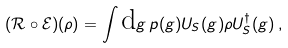<formula> <loc_0><loc_0><loc_500><loc_500>( \mathcal { R } \circ \mathcal { E } ) ( \rho ) = \int \text {d} g \, p ( g ) U _ { S } ( g ) \rho U _ { S } ^ { \dag } ( g ) \, ,</formula> 